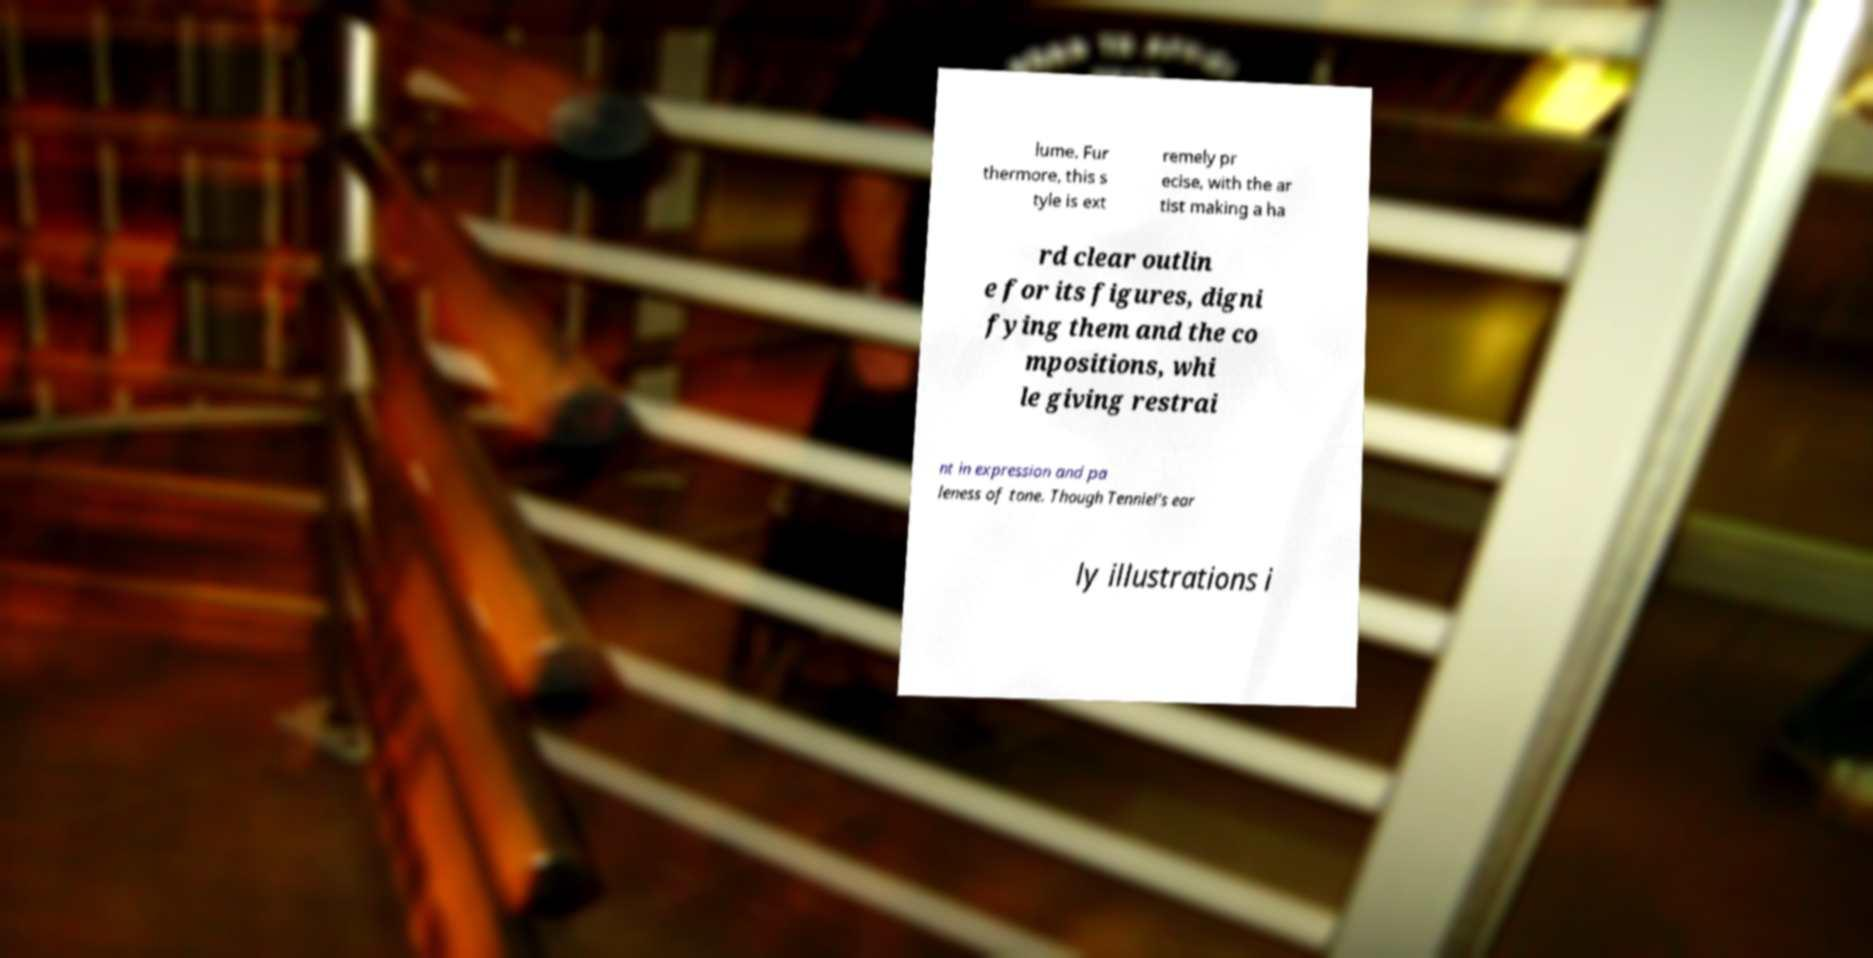Please read and relay the text visible in this image. What does it say? lume. Fur thermore, this s tyle is ext remely pr ecise, with the ar tist making a ha rd clear outlin e for its figures, digni fying them and the co mpositions, whi le giving restrai nt in expression and pa leness of tone. Though Tenniel's ear ly illustrations i 